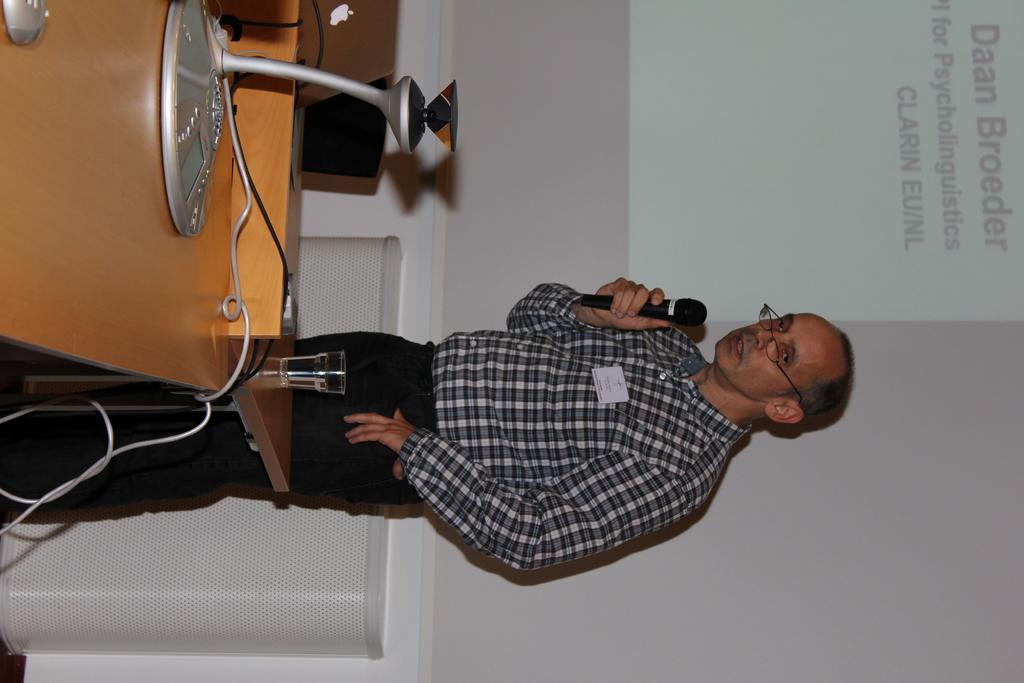Describe this image in one or two sentences. In the image there is a man who is standing holding a microphone opened his mouth for talking in front of a man there is a table. On table we can see a glass,speaker,laptop. In background we can see a screen and white color wall. 